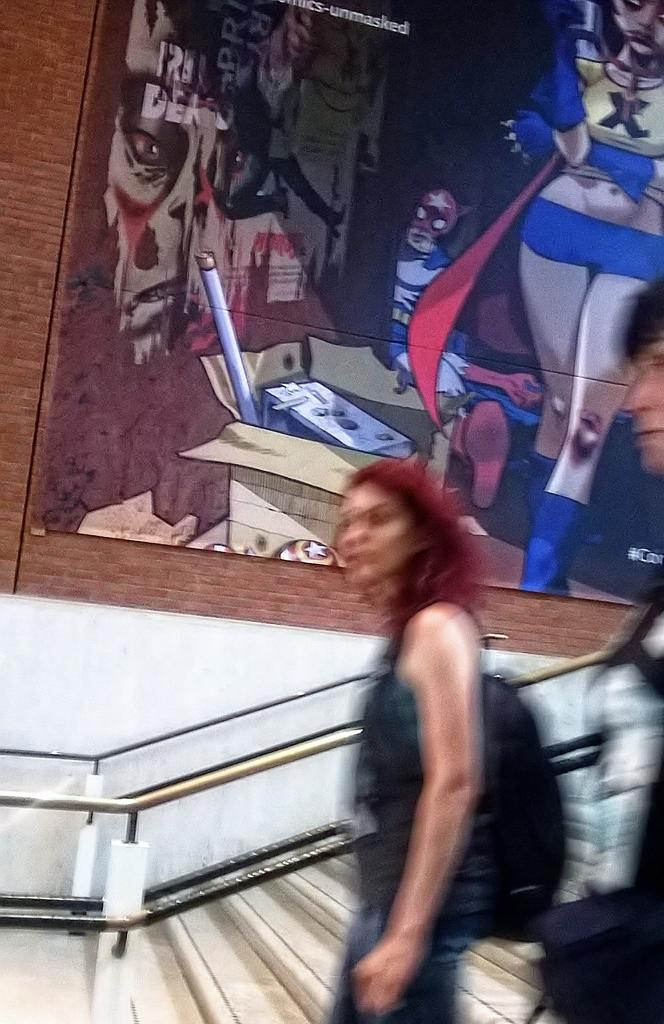What is featured on the poster in the image? The facts do not specify what is on the poster, so we cannot answer this question definitively. What can be seen in the image besides the poster? There are people and stairs in the image. What might be used for safety or support on the stairs? There is a railing in the image, which can be used for safety or support. What type of teaching is happening in the image? There is no indication of teaching or any educational activity in the image. --- 